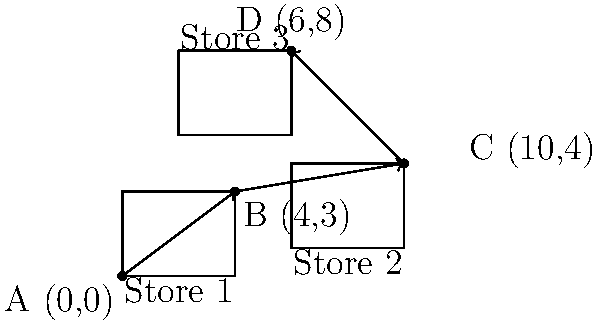A shopper starts at Store 1 (point A) and compares prices across three online stores. The journey to find the best deal can be represented by composite transformations. If the shopper moves from Store 1 to Store 2, then to Store 3, and finally back to Store 1, what is the resulting transformation that brings the shopper back to the starting point?

Given:
- From A(0,0) to B(4,3): Translation by vector $\vec{v_1} = \langle 4, 3 \rangle$
- From B(4,3) to C(10,4): Translation by vector $\vec{v_2} = \langle 6, 1 \rangle$
- From C(10,4) to D(6,8): Translation by vector $\vec{v_3} = \langle -4, 4 \rangle$
- From D(6,8) back to A(0,0): Final transformation to be determined

Express the final transformation as a single translation vector. Let's approach this step-by-step:

1) First, we need to add up all the translation vectors to get the total displacement:

   $\vec{v_{total}} = \vec{v_1} + \vec{v_2} + \vec{v_3} + \vec{v_{final}}$

2) We know that the total displacement should be zero since the shopper ends up back at the starting point:

   $\vec{v_{total}} = \langle 0, 0 \rangle$

3) Let's substitute the known vectors:

   $\langle 0, 0 \rangle = \langle 4, 3 \rangle + \langle 6, 1 \rangle + \langle -4, 4 \rangle + \vec{v_{final}}$

4) Add up the known vectors:

   $\langle 0, 0 \rangle = \langle 6, 8 \rangle + \vec{v_{final}}$

5) To find $\vec{v_{final}}$, we need to solve:

   $\vec{v_{final}} = \langle 0, 0 \rangle - \langle 6, 8 \rangle = \langle -6, -8 \rangle$

Therefore, the final transformation that brings the shopper back to the starting point is a translation by vector $\langle -6, -8 \rangle$.
Answer: Translation by vector $\langle -6, -8 \rangle$ 